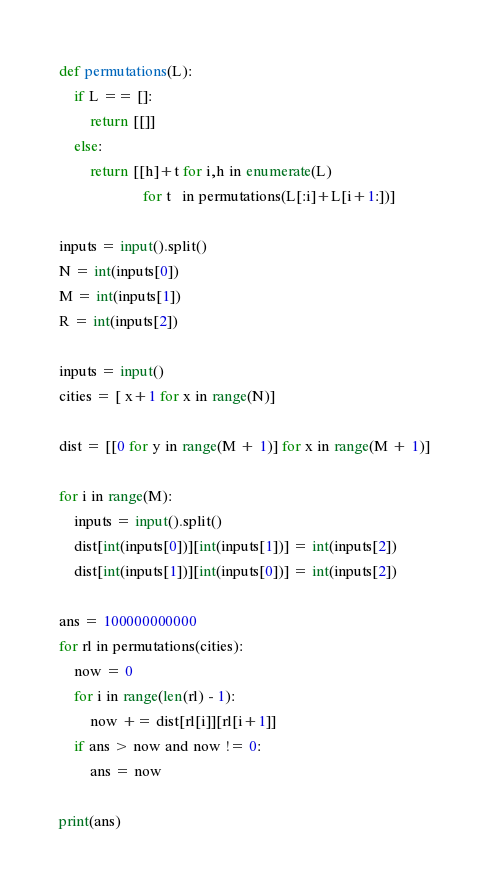Convert code to text. <code><loc_0><loc_0><loc_500><loc_500><_Python_>def permutations(L):
    if L == []:
        return [[]]
    else:
        return [[h]+t for i,h in enumerate(L)
                      for t   in permutations(L[:i]+L[i+1:])]

inputs = input().split()
N = int(inputs[0])
M = int(inputs[1])
R = int(inputs[2])

inputs = input()
cities = [ x+1 for x in range(N)]

dist = [[0 for y in range(M + 1)] for x in range(M + 1)]

for i in range(M):
    inputs = input().split()
    dist[int(inputs[0])][int(inputs[1])] = int(inputs[2])
    dist[int(inputs[1])][int(inputs[0])] = int(inputs[2])

ans = 100000000000
for rl in permutations(cities):
    now = 0
    for i in range(len(rl) - 1):
        now += dist[rl[i]][rl[i+1]]
    if ans > now and now != 0:
        ans = now

print(ans)</code> 